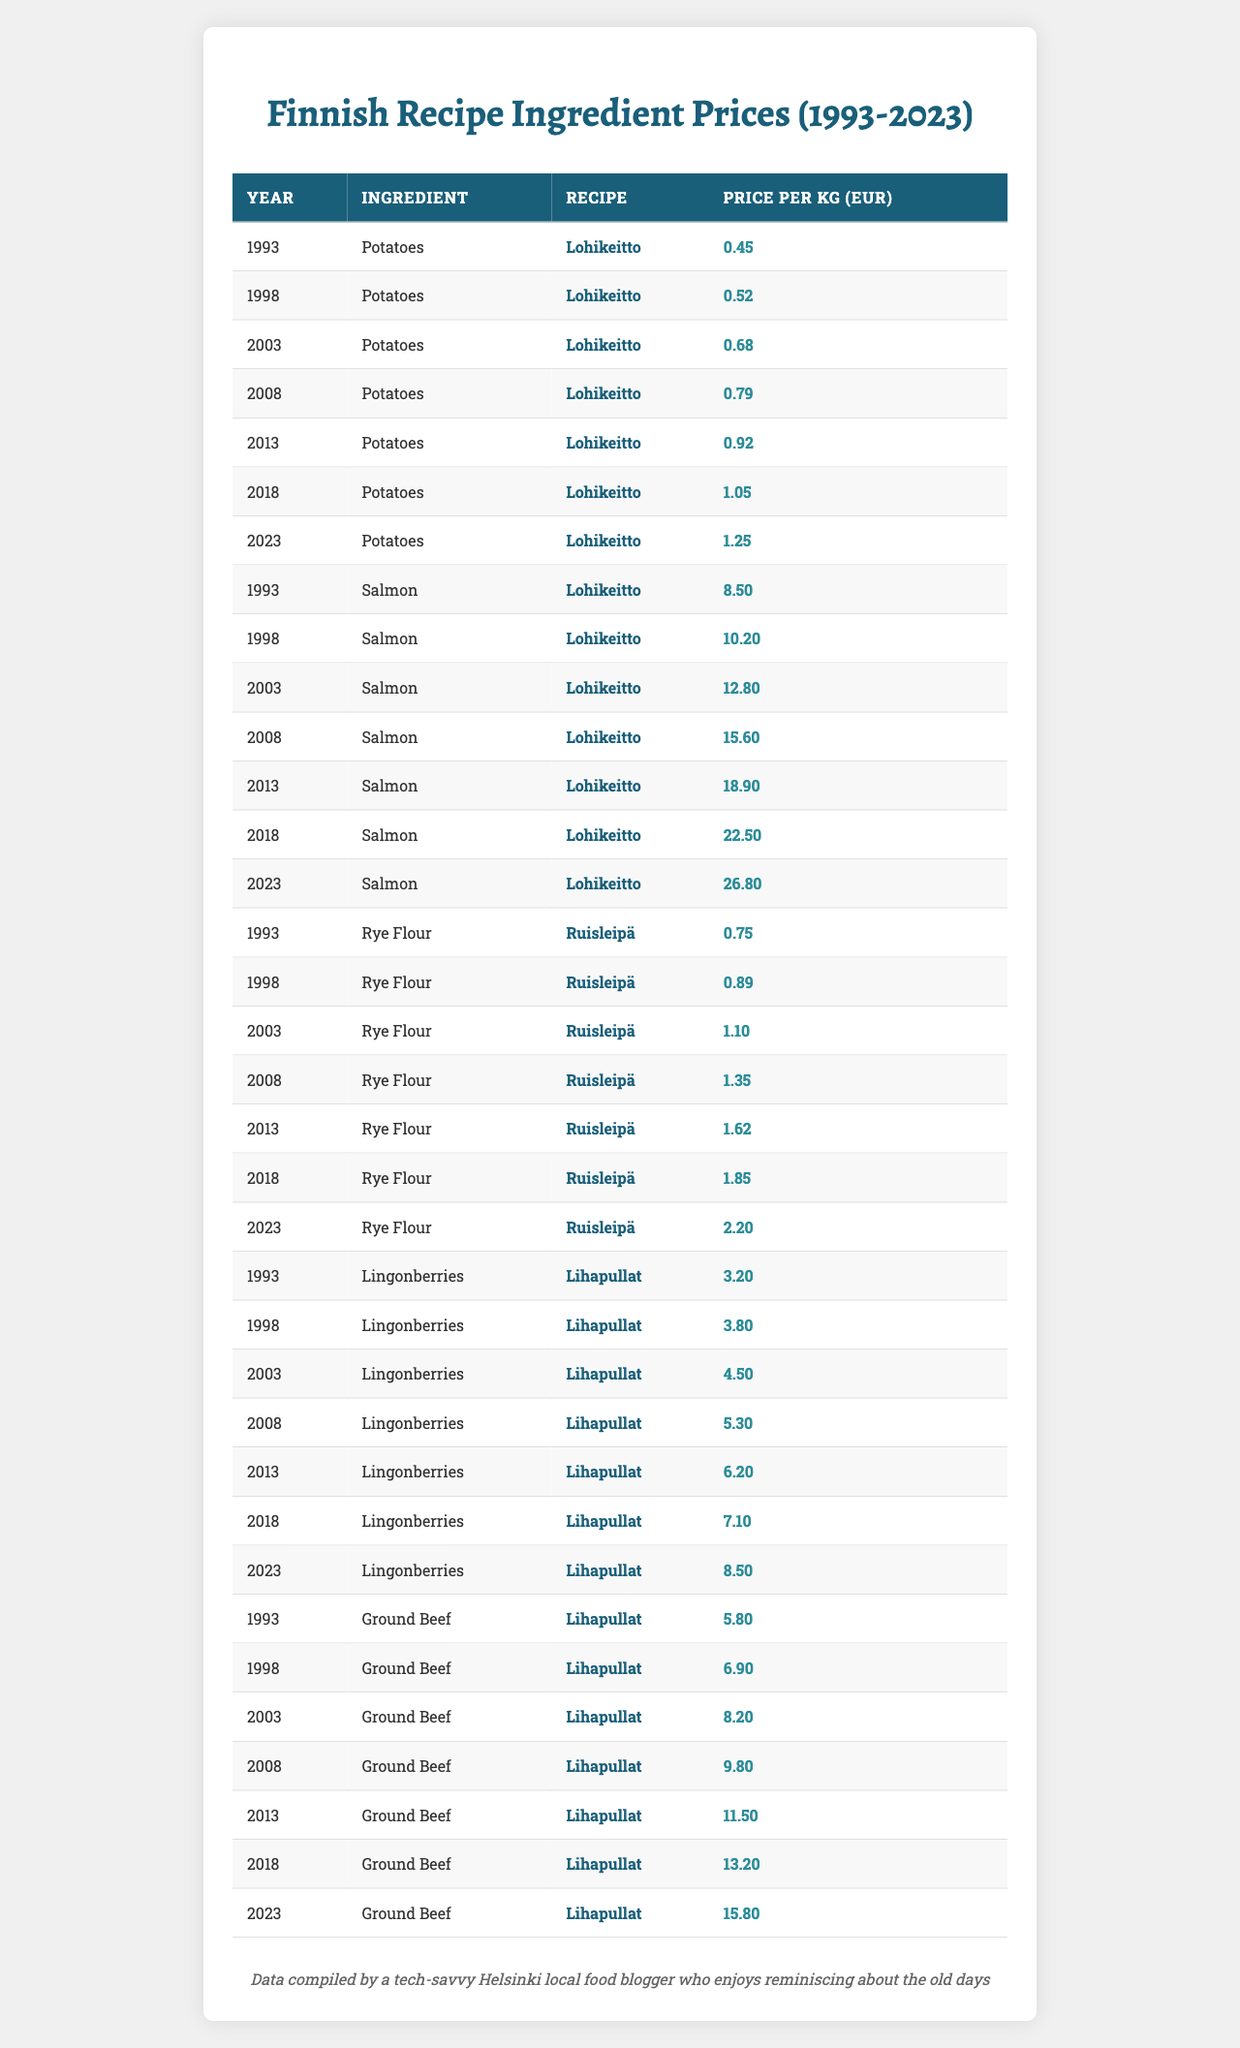What was the price per kg of Potatoes in 2013? In the table, I locate the row with the year 2013 and the ingredient Potatoes, which shows the price as 0.92 EUR per kg.
Answer: 0.92 EUR Which ingredient had the highest price per kg in 2023? I look at the prices for each ingredient in the year 2023. Salmon has the highest price listed at 26.80 EUR per kg.
Answer: Salmon What is the price difference for Ground Beef between 1993 and 2023? The price for Ground Beef in 1993 is 5.80 EUR per kg, and in 2023 it is 15.80 EUR per kg. The difference is calculated as 15.80 - 5.80 = 10.00.
Answer: 10.00 EUR What was the average price per kg of Lingonberries from 1993 to 2023? To find the average, I sum the prices for Lingonberries over the seven years: (3.20 + 3.80 + 4.50 + 5.30 + 6.20 + 7.10 + 8.50) = 38.60. Then I divide by 7, which gives approximately 5.51.
Answer: 5.51 EUR Did the price of Rye Flour decrease at any point from 1993 to 2023? I check the prices over the years and see that Rye Flour's prices only increased from 0.75 EUR in 1993 to 2.20 EUR in 2023, indicating no decrease.
Answer: No What was the percentage increase in the price of Salmon from 1993 to 2023? The price in 1993 was 8.50 EUR and in 2023 it was 26.80 EUR. The increase is 26.80 - 8.50 = 18.30. The percentage increase is (18.30 / 8.50) * 100 = 215.29%.
Answer: 215.29% Which year saw the largest price increase for Potatoes from the previous year? I compare the yearly prices for Potatoes and find the largest difference between consecutive years. The increase from 2018 (1.05 EUR) to 2023 (1.25 EUR) was 0.20 EUR. Similarly, the largest increase was from 2008 (0.79 EUR) to 2013 (0.92 EUR) at 0.13 EUR. Thus, the largest increase is between 2018 and 2023.
Answer: 0.20 EUR What is the trend in the prices of ingredients for Lohikeitto from 1993 to 2023? I analyze the prices of both Potatoes and Salmon from the table, noting that both ingredients have shown a consistent increase over the years, indicating a general upward trend in prices.
Answer: Increasing trend Which ingredient for Ruisleipä had the lowest price in 1998? Looking specifically for Ruisleipä in 1998, I find that Rye Flour had a price of 0.89 EUR, which is the only ingredient listed for this recipe, thus it is the lowest.
Answer: Rye Flour at 0.89 EUR 